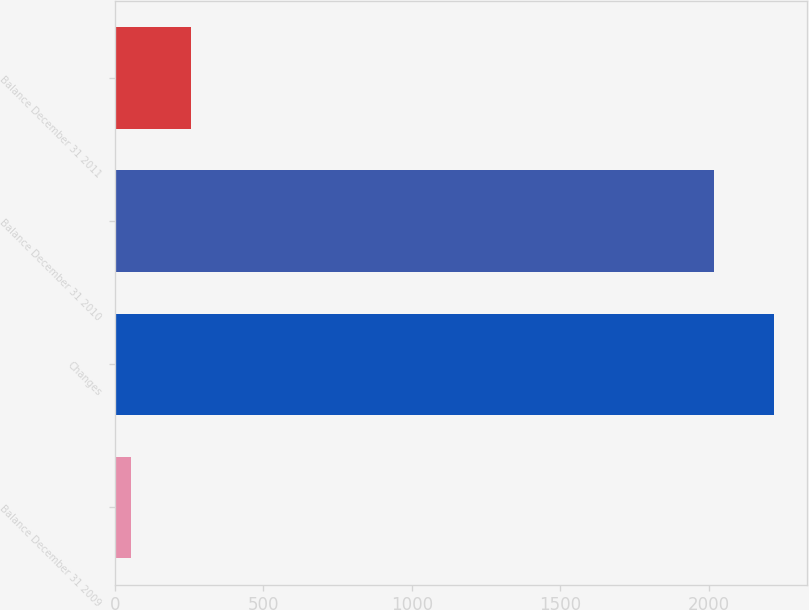Convert chart to OTSL. <chart><loc_0><loc_0><loc_500><loc_500><bar_chart><fcel>Balance December 31 2009<fcel>Changes<fcel>Balance December 31 2010<fcel>Balance December 31 2011<nl><fcel>55<fcel>2218.7<fcel>2017<fcel>256.7<nl></chart> 